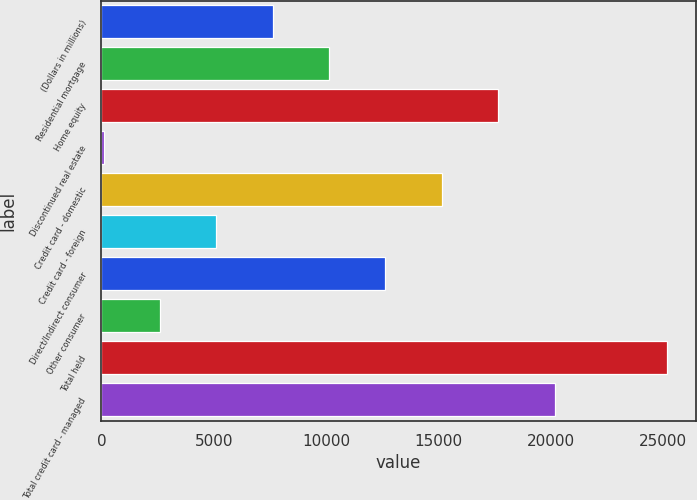Convert chart. <chart><loc_0><loc_0><loc_500><loc_500><bar_chart><fcel>(Dollars in millions)<fcel>Residential mortgage<fcel>Home equity<fcel>Discontinued real estate<fcel>Credit card - domestic<fcel>Credit card - foreign<fcel>Direct/Indirect consumer<fcel>Other consumer<fcel>Total held<fcel>Total credit card - managed<nl><fcel>7624.1<fcel>10131.8<fcel>17654.9<fcel>101<fcel>15147.2<fcel>5116.4<fcel>12639.5<fcel>2608.7<fcel>25178<fcel>20162.6<nl></chart> 